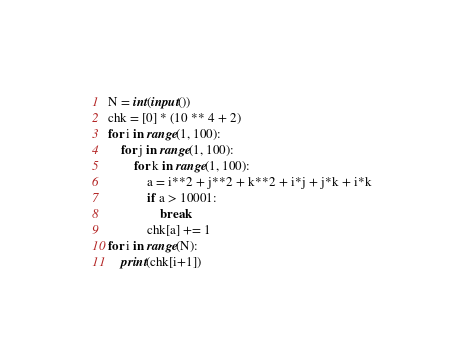<code> <loc_0><loc_0><loc_500><loc_500><_Python_>N = int(input())
chk = [0] * (10 ** 4 + 2)
for i in range(1, 100):
    for j in range(1, 100):
        for k in range(1, 100):
            a = i**2 + j**2 + k**2 + i*j + j*k + i*k
            if a > 10001:
                break
            chk[a] += 1
for i in range(N):
    print(chk[i+1])</code> 